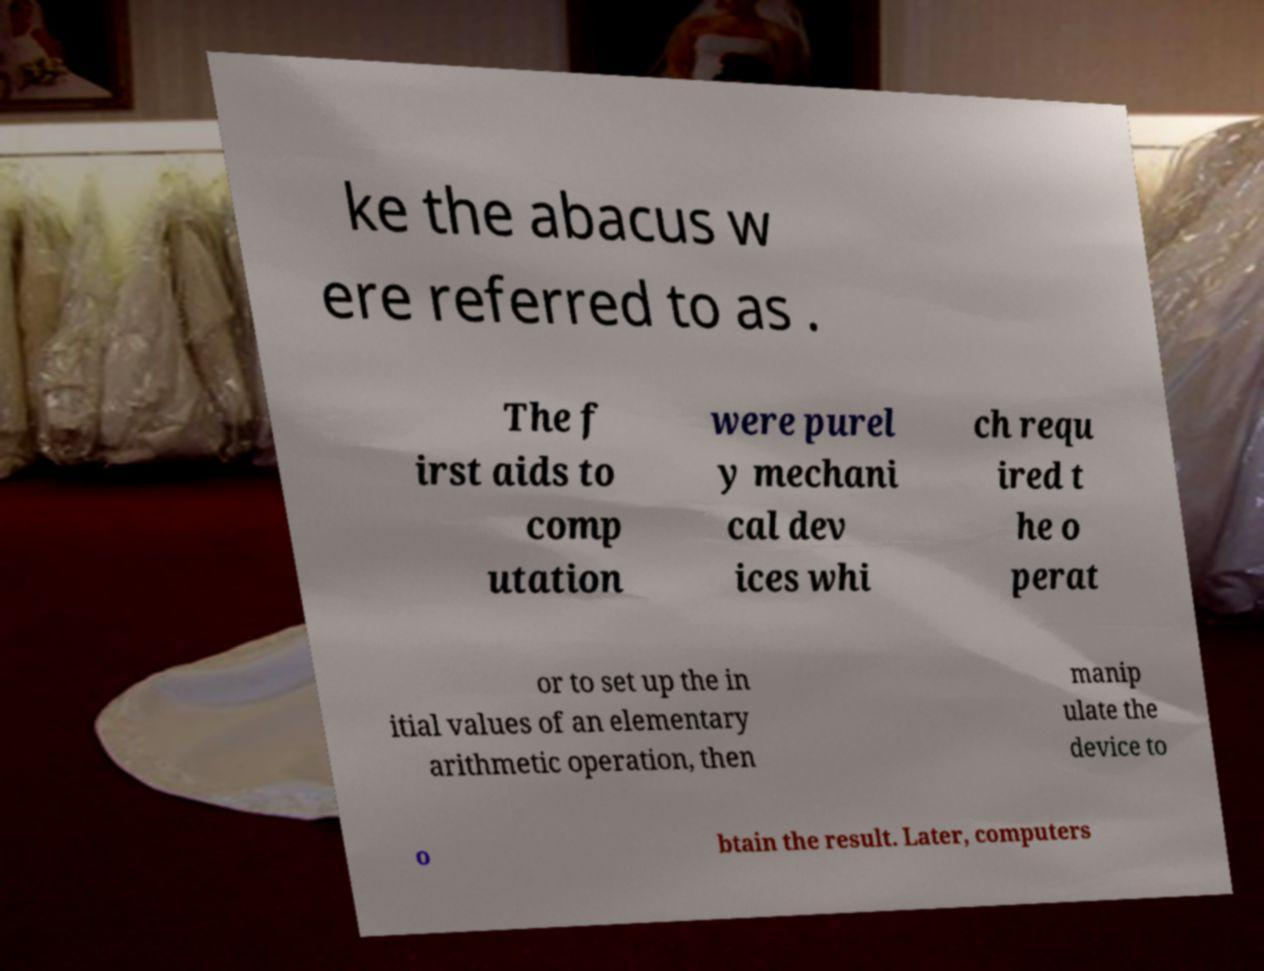I need the written content from this picture converted into text. Can you do that? ke the abacus w ere referred to as . The f irst aids to comp utation were purel y mechani cal dev ices whi ch requ ired t he o perat or to set up the in itial values of an elementary arithmetic operation, then manip ulate the device to o btain the result. Later, computers 